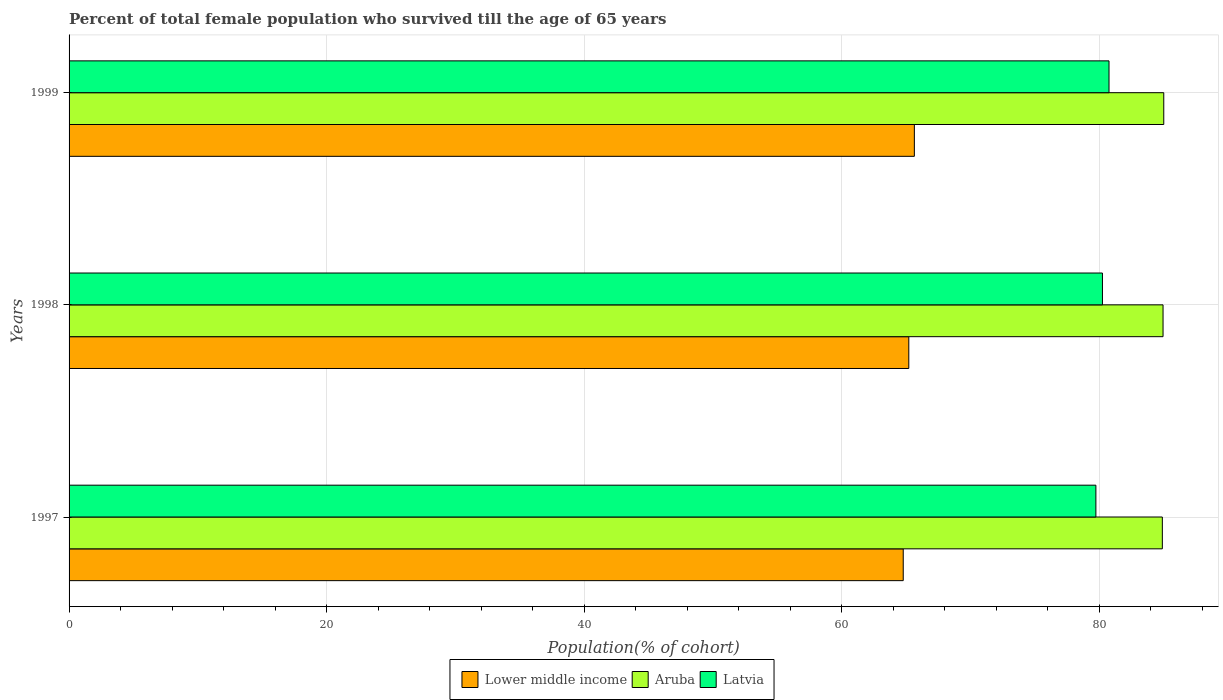How many different coloured bars are there?
Keep it short and to the point. 3. How many groups of bars are there?
Provide a short and direct response. 3. Are the number of bars on each tick of the Y-axis equal?
Offer a very short reply. Yes. How many bars are there on the 2nd tick from the top?
Provide a short and direct response. 3. How many bars are there on the 3rd tick from the bottom?
Provide a succinct answer. 3. What is the percentage of total female population who survived till the age of 65 years in Lower middle income in 1999?
Provide a succinct answer. 65.65. Across all years, what is the maximum percentage of total female population who survived till the age of 65 years in Latvia?
Make the answer very short. 80.77. Across all years, what is the minimum percentage of total female population who survived till the age of 65 years in Latvia?
Ensure brevity in your answer.  79.75. In which year was the percentage of total female population who survived till the age of 65 years in Aruba maximum?
Provide a succinct answer. 1999. In which year was the percentage of total female population who survived till the age of 65 years in Aruba minimum?
Provide a succinct answer. 1997. What is the total percentage of total female population who survived till the age of 65 years in Latvia in the graph?
Your answer should be very brief. 240.77. What is the difference between the percentage of total female population who survived till the age of 65 years in Latvia in 1997 and that in 1999?
Keep it short and to the point. -1.02. What is the difference between the percentage of total female population who survived till the age of 65 years in Lower middle income in 1998 and the percentage of total female population who survived till the age of 65 years in Aruba in 1999?
Your response must be concise. -19.8. What is the average percentage of total female population who survived till the age of 65 years in Aruba per year?
Provide a short and direct response. 84.96. In the year 1997, what is the difference between the percentage of total female population who survived till the age of 65 years in Latvia and percentage of total female population who survived till the age of 65 years in Aruba?
Make the answer very short. -5.16. What is the ratio of the percentage of total female population who survived till the age of 65 years in Latvia in 1997 to that in 1998?
Provide a succinct answer. 0.99. Is the percentage of total female population who survived till the age of 65 years in Lower middle income in 1997 less than that in 1999?
Ensure brevity in your answer.  Yes. Is the difference between the percentage of total female population who survived till the age of 65 years in Latvia in 1998 and 1999 greater than the difference between the percentage of total female population who survived till the age of 65 years in Aruba in 1998 and 1999?
Offer a very short reply. No. What is the difference between the highest and the second highest percentage of total female population who survived till the age of 65 years in Latvia?
Provide a short and direct response. 0.51. What is the difference between the highest and the lowest percentage of total female population who survived till the age of 65 years in Latvia?
Your answer should be very brief. 1.02. Is the sum of the percentage of total female population who survived till the age of 65 years in Aruba in 1998 and 1999 greater than the maximum percentage of total female population who survived till the age of 65 years in Latvia across all years?
Give a very brief answer. Yes. What does the 2nd bar from the top in 1998 represents?
Ensure brevity in your answer.  Aruba. What does the 3rd bar from the bottom in 1997 represents?
Offer a very short reply. Latvia. Is it the case that in every year, the sum of the percentage of total female population who survived till the age of 65 years in Lower middle income and percentage of total female population who survived till the age of 65 years in Latvia is greater than the percentage of total female population who survived till the age of 65 years in Aruba?
Offer a very short reply. Yes. How many years are there in the graph?
Make the answer very short. 3. What is the difference between two consecutive major ticks on the X-axis?
Your response must be concise. 20. Are the values on the major ticks of X-axis written in scientific E-notation?
Provide a short and direct response. No. Does the graph contain grids?
Offer a very short reply. Yes. How many legend labels are there?
Your answer should be compact. 3. How are the legend labels stacked?
Ensure brevity in your answer.  Horizontal. What is the title of the graph?
Offer a very short reply. Percent of total female population who survived till the age of 65 years. What is the label or title of the X-axis?
Offer a terse response. Population(% of cohort). What is the Population(% of cohort) of Lower middle income in 1997?
Provide a succinct answer. 64.79. What is the Population(% of cohort) in Aruba in 1997?
Offer a very short reply. 84.91. What is the Population(% of cohort) of Latvia in 1997?
Your answer should be compact. 79.75. What is the Population(% of cohort) of Lower middle income in 1998?
Make the answer very short. 65.22. What is the Population(% of cohort) of Aruba in 1998?
Make the answer very short. 84.96. What is the Population(% of cohort) of Latvia in 1998?
Provide a short and direct response. 80.26. What is the Population(% of cohort) in Lower middle income in 1999?
Your answer should be very brief. 65.65. What is the Population(% of cohort) of Aruba in 1999?
Make the answer very short. 85.02. What is the Population(% of cohort) in Latvia in 1999?
Provide a succinct answer. 80.77. Across all years, what is the maximum Population(% of cohort) in Lower middle income?
Offer a terse response. 65.65. Across all years, what is the maximum Population(% of cohort) of Aruba?
Keep it short and to the point. 85.02. Across all years, what is the maximum Population(% of cohort) of Latvia?
Keep it short and to the point. 80.77. Across all years, what is the minimum Population(% of cohort) of Lower middle income?
Make the answer very short. 64.79. Across all years, what is the minimum Population(% of cohort) of Aruba?
Provide a short and direct response. 84.91. Across all years, what is the minimum Population(% of cohort) in Latvia?
Offer a very short reply. 79.75. What is the total Population(% of cohort) of Lower middle income in the graph?
Your response must be concise. 195.65. What is the total Population(% of cohort) of Aruba in the graph?
Offer a very short reply. 254.89. What is the total Population(% of cohort) of Latvia in the graph?
Offer a terse response. 240.77. What is the difference between the Population(% of cohort) in Lower middle income in 1997 and that in 1998?
Your answer should be compact. -0.43. What is the difference between the Population(% of cohort) of Aruba in 1997 and that in 1998?
Provide a short and direct response. -0.06. What is the difference between the Population(% of cohort) in Latvia in 1997 and that in 1998?
Make the answer very short. -0.51. What is the difference between the Population(% of cohort) of Lower middle income in 1997 and that in 1999?
Ensure brevity in your answer.  -0.86. What is the difference between the Population(% of cohort) in Aruba in 1997 and that in 1999?
Keep it short and to the point. -0.11. What is the difference between the Population(% of cohort) of Latvia in 1997 and that in 1999?
Ensure brevity in your answer.  -1.02. What is the difference between the Population(% of cohort) in Lower middle income in 1998 and that in 1999?
Give a very brief answer. -0.43. What is the difference between the Population(% of cohort) of Aruba in 1998 and that in 1999?
Offer a very short reply. -0.06. What is the difference between the Population(% of cohort) of Latvia in 1998 and that in 1999?
Your answer should be very brief. -0.51. What is the difference between the Population(% of cohort) in Lower middle income in 1997 and the Population(% of cohort) in Aruba in 1998?
Keep it short and to the point. -20.18. What is the difference between the Population(% of cohort) in Lower middle income in 1997 and the Population(% of cohort) in Latvia in 1998?
Offer a very short reply. -15.47. What is the difference between the Population(% of cohort) of Aruba in 1997 and the Population(% of cohort) of Latvia in 1998?
Give a very brief answer. 4.65. What is the difference between the Population(% of cohort) of Lower middle income in 1997 and the Population(% of cohort) of Aruba in 1999?
Your response must be concise. -20.23. What is the difference between the Population(% of cohort) in Lower middle income in 1997 and the Population(% of cohort) in Latvia in 1999?
Your answer should be very brief. -15.98. What is the difference between the Population(% of cohort) in Aruba in 1997 and the Population(% of cohort) in Latvia in 1999?
Provide a short and direct response. 4.14. What is the difference between the Population(% of cohort) of Lower middle income in 1998 and the Population(% of cohort) of Aruba in 1999?
Ensure brevity in your answer.  -19.8. What is the difference between the Population(% of cohort) of Lower middle income in 1998 and the Population(% of cohort) of Latvia in 1999?
Make the answer very short. -15.55. What is the difference between the Population(% of cohort) in Aruba in 1998 and the Population(% of cohort) in Latvia in 1999?
Provide a succinct answer. 4.2. What is the average Population(% of cohort) of Lower middle income per year?
Your response must be concise. 65.22. What is the average Population(% of cohort) of Aruba per year?
Your answer should be compact. 84.96. What is the average Population(% of cohort) in Latvia per year?
Provide a succinct answer. 80.26. In the year 1997, what is the difference between the Population(% of cohort) in Lower middle income and Population(% of cohort) in Aruba?
Make the answer very short. -20.12. In the year 1997, what is the difference between the Population(% of cohort) of Lower middle income and Population(% of cohort) of Latvia?
Give a very brief answer. -14.96. In the year 1997, what is the difference between the Population(% of cohort) in Aruba and Population(% of cohort) in Latvia?
Provide a short and direct response. 5.16. In the year 1998, what is the difference between the Population(% of cohort) of Lower middle income and Population(% of cohort) of Aruba?
Make the answer very short. -19.75. In the year 1998, what is the difference between the Population(% of cohort) of Lower middle income and Population(% of cohort) of Latvia?
Provide a short and direct response. -15.04. In the year 1998, what is the difference between the Population(% of cohort) of Aruba and Population(% of cohort) of Latvia?
Your answer should be compact. 4.71. In the year 1999, what is the difference between the Population(% of cohort) in Lower middle income and Population(% of cohort) in Aruba?
Make the answer very short. -19.37. In the year 1999, what is the difference between the Population(% of cohort) in Lower middle income and Population(% of cohort) in Latvia?
Provide a short and direct response. -15.12. In the year 1999, what is the difference between the Population(% of cohort) in Aruba and Population(% of cohort) in Latvia?
Offer a very short reply. 4.25. What is the ratio of the Population(% of cohort) in Lower middle income in 1997 to that in 1998?
Make the answer very short. 0.99. What is the ratio of the Population(% of cohort) of Aruba in 1997 to that in 1998?
Make the answer very short. 1. What is the ratio of the Population(% of cohort) of Latvia in 1997 to that in 1998?
Provide a short and direct response. 0.99. What is the ratio of the Population(% of cohort) of Aruba in 1997 to that in 1999?
Offer a terse response. 1. What is the ratio of the Population(% of cohort) of Latvia in 1997 to that in 1999?
Your response must be concise. 0.99. What is the ratio of the Population(% of cohort) of Lower middle income in 1998 to that in 1999?
Give a very brief answer. 0.99. What is the ratio of the Population(% of cohort) of Aruba in 1998 to that in 1999?
Provide a short and direct response. 1. What is the difference between the highest and the second highest Population(% of cohort) in Lower middle income?
Provide a short and direct response. 0.43. What is the difference between the highest and the second highest Population(% of cohort) in Aruba?
Make the answer very short. 0.06. What is the difference between the highest and the second highest Population(% of cohort) in Latvia?
Offer a very short reply. 0.51. What is the difference between the highest and the lowest Population(% of cohort) in Lower middle income?
Provide a succinct answer. 0.86. What is the difference between the highest and the lowest Population(% of cohort) of Aruba?
Offer a very short reply. 0.11. What is the difference between the highest and the lowest Population(% of cohort) of Latvia?
Your response must be concise. 1.02. 